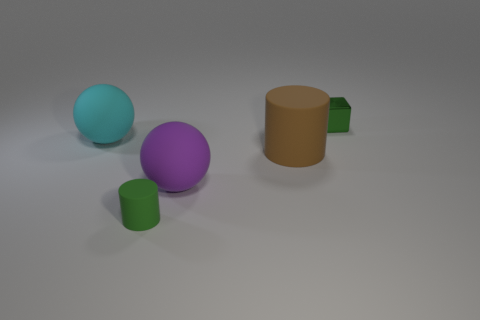Add 3 large brown things. How many objects exist? 8 Subtract 1 green cubes. How many objects are left? 4 Subtract all blocks. How many objects are left? 4 Subtract all cyan spheres. Subtract all green blocks. How many spheres are left? 1 Subtract all cyan cylinders. How many gray cubes are left? 0 Subtract all tiny green things. Subtract all green shiny things. How many objects are left? 2 Add 2 rubber balls. How many rubber balls are left? 4 Add 3 tiny metal objects. How many tiny metal objects exist? 4 Subtract all green cylinders. How many cylinders are left? 1 